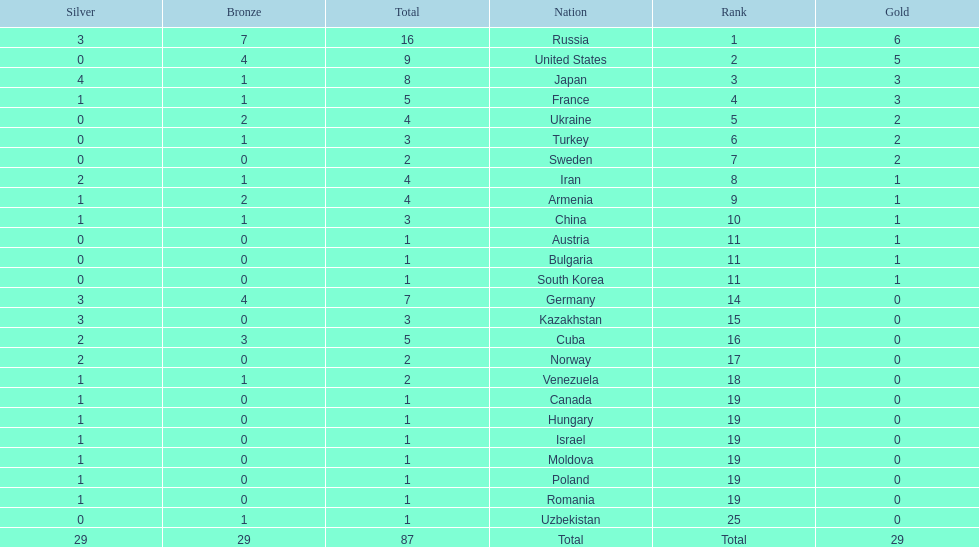Which nations have gold medals? Russia, United States, Japan, France, Ukraine, Turkey, Sweden, Iran, Armenia, China, Austria, Bulgaria, South Korea. Of those nations, which have only one gold medal? Iran, Armenia, China, Austria, Bulgaria, South Korea. Of those nations, which has no bronze or silver medals? Austria. 